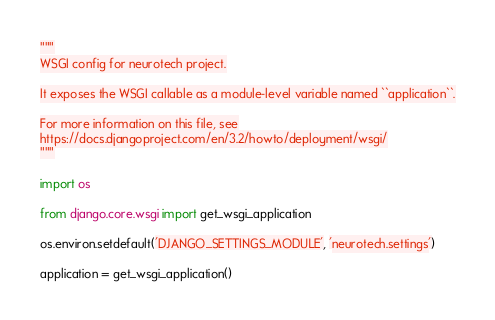Convert code to text. <code><loc_0><loc_0><loc_500><loc_500><_Python_>"""
WSGI config for neurotech project.

It exposes the WSGI callable as a module-level variable named ``application``.

For more information on this file, see
https://docs.djangoproject.com/en/3.2/howto/deployment/wsgi/
"""

import os

from django.core.wsgi import get_wsgi_application

os.environ.setdefault('DJANGO_SETTINGS_MODULE', 'neurotech.settings')

application = get_wsgi_application()
</code> 